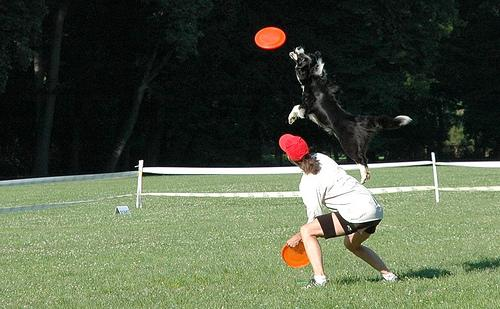What is the dog ready to do? catch 